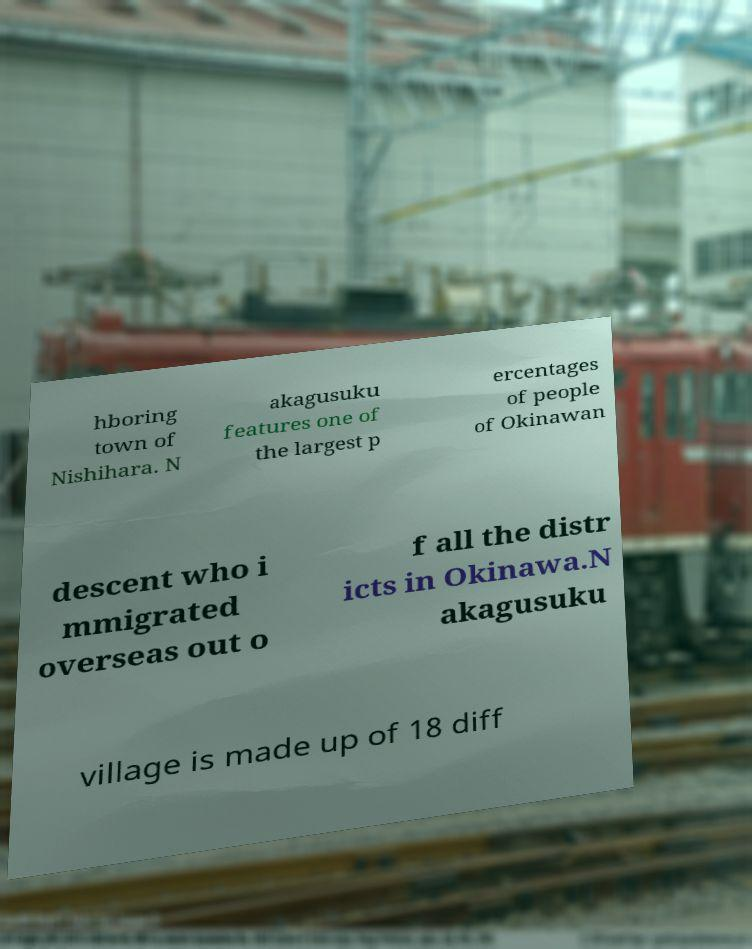Can you accurately transcribe the text from the provided image for me? hboring town of Nishihara. N akagusuku features one of the largest p ercentages of people of Okinawan descent who i mmigrated overseas out o f all the distr icts in Okinawa.N akagusuku village is made up of 18 diff 